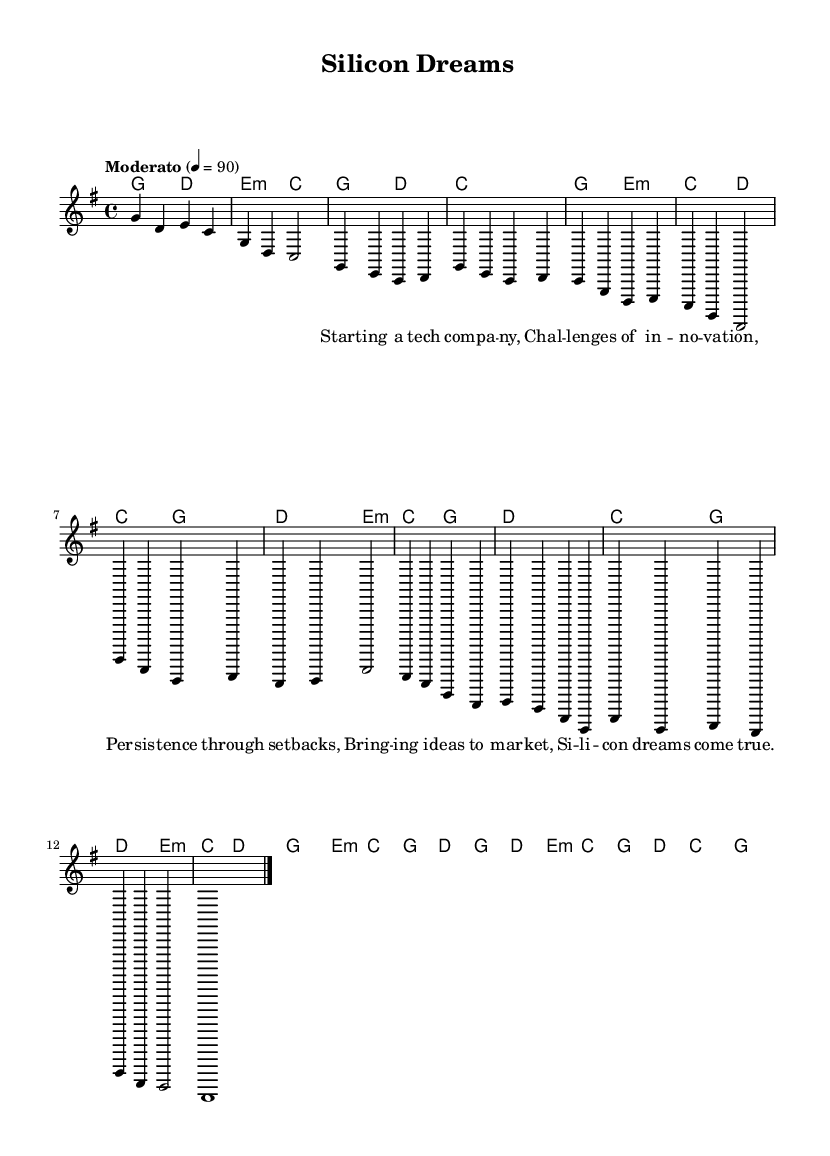What is the key signature of this music? The key signature is G major, which has one sharp (F#). You can determine this by looking at the key signature indicated at the beginning of the score.
Answer: G major What is the time signature of this music? The time signature is 4/4, which means there are four beats in each measure and a quarter note gets one beat. This is indicated at the beginning of the score.
Answer: 4/4 What is the tempo marking of this music? The tempo marking is Moderato, which typically indicates a moderate speed of performance. This is mentioned in the tempo directive at the start of the piece.
Answer: Moderato How many measures are in the chorus section? The chorus section consists of four measures. You can count the measures in the respective part of the score that contains the chorus text.
Answer: Four measures What chord is played in the introduction? The chord played in the introduction is G. You can find this by looking at the chord symbols above the measures in the introduction section.
Answer: G In which section does the line "Bringing ideas to market" appear? The line "Bringing ideas to market" appears in the bridge of the song. This can be identified by the specific lyrics aligned with the music notation in the bridge section.
Answer: Bridge Which musical form is predominant in this piece? The predominant musical form is verse-chorus structure. This can be inferred from the repeated sections of verses followed by a chorus, typical in folk music.
Answer: Verse-chorus 